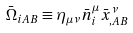<formula> <loc_0><loc_0><loc_500><loc_500>\bar { \Omega } _ { i A B } \equiv \eta _ { \mu \nu } \bar { n } ^ { \mu } _ { i } \bar { x } ^ { \nu } _ { , A B }</formula> 